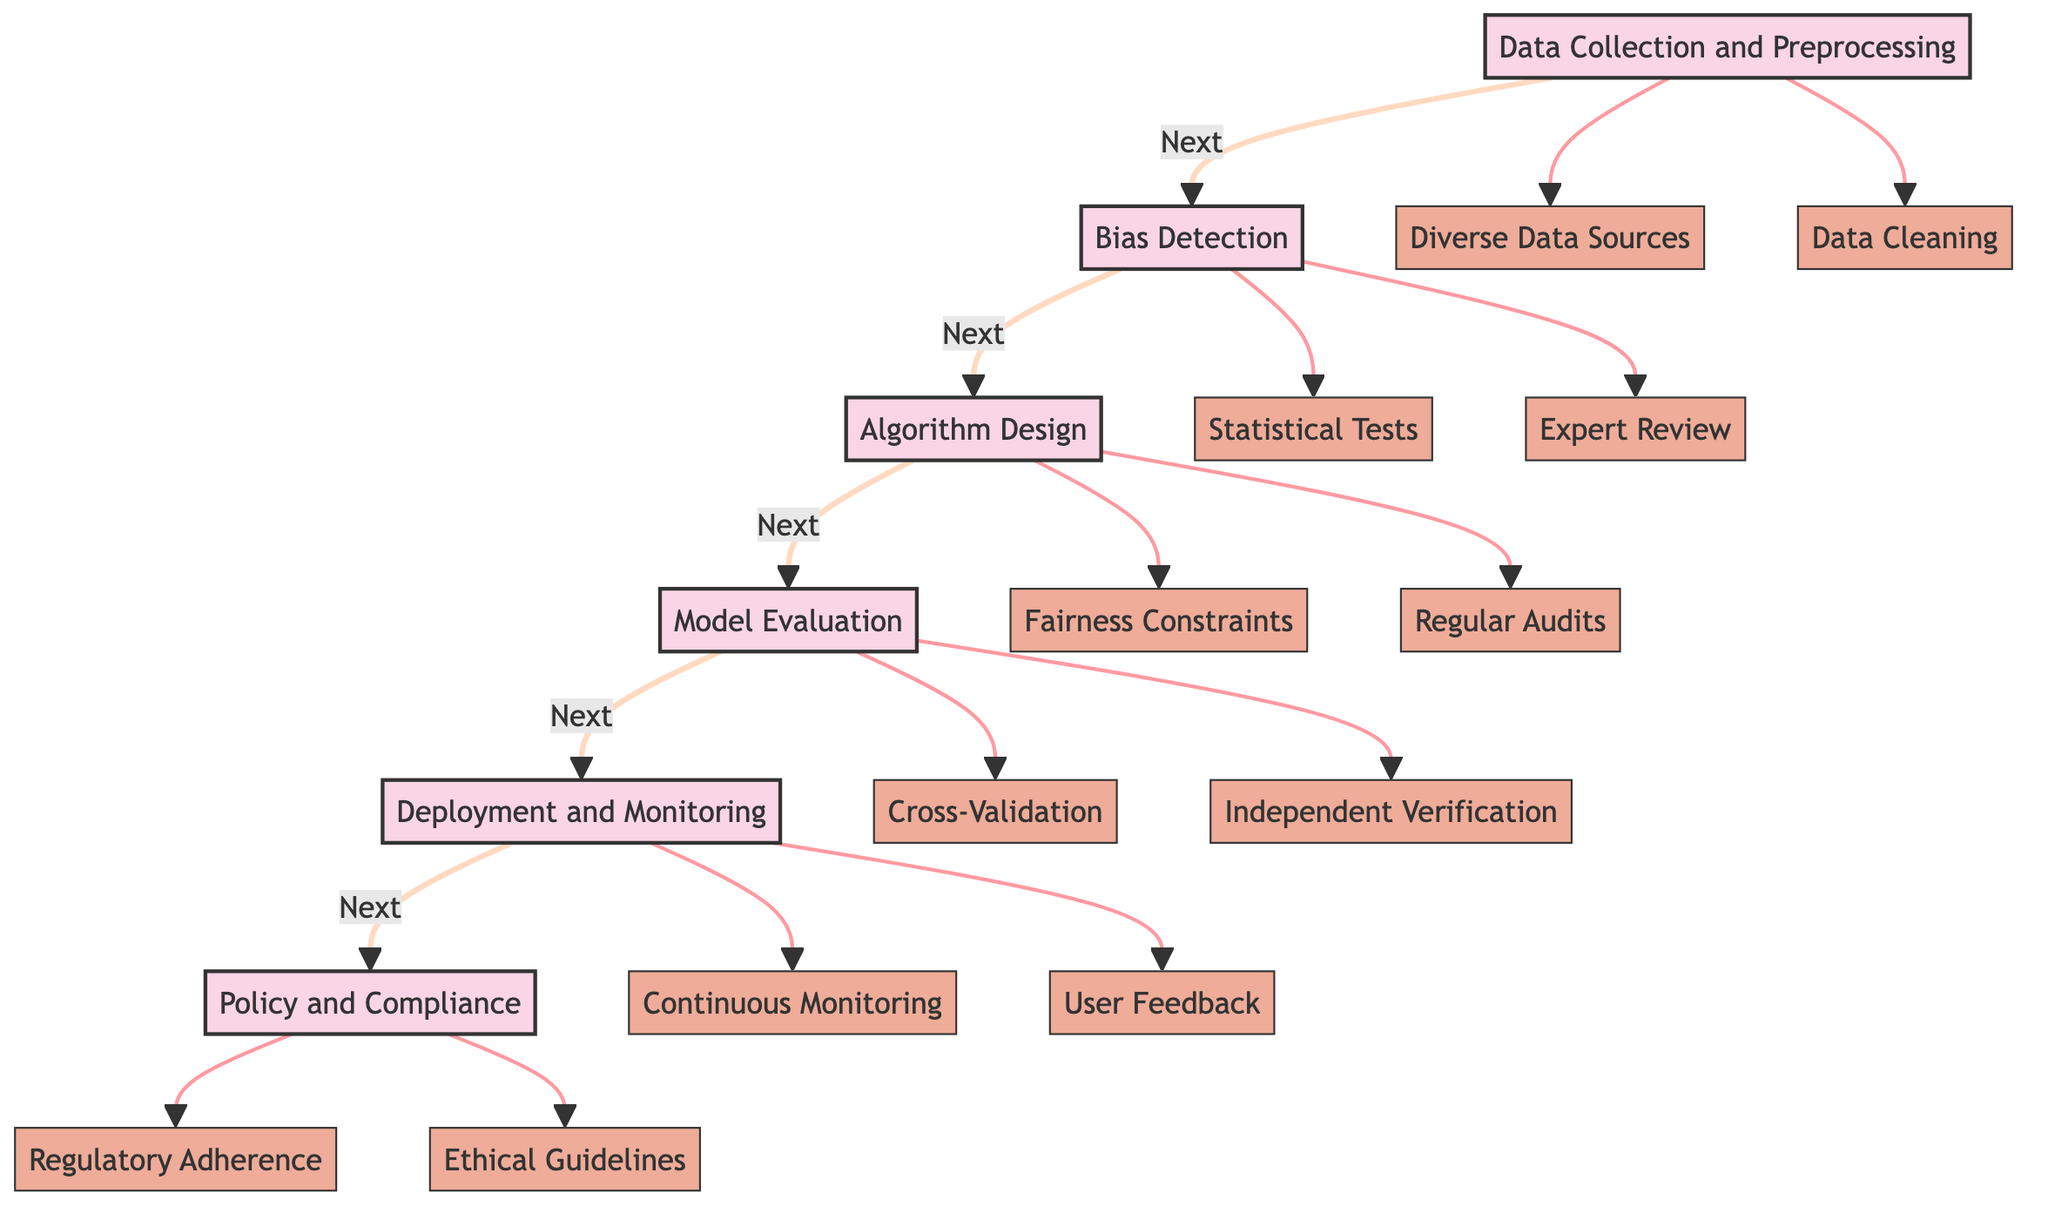What is the first step in the pathway? The diagram indicates that the first step in the pathway is "Data Collection and Preprocessing." This is the starting point of the clinical recommendations process as shown by the arrow leading from A to B.
Answer: Data Collection and Preprocessing How many main steps are shown in the diagram? The diagram consists of six main steps: 1) Data Collection and Preprocessing, 2) Bias Detection, 3) Algorithm Design, 4) Model Evaluation, 5) Deployment and Monitoring, 6) Policy and Compliance. This can be counted from the steps indicated in the flow.
Answer: Six What are the two elements under "Bias Detection"? The two elements listed under "Bias Detection" are "Statistical Tests" and "Expert Review." This information is derived from the elements categorized under the Bias Detection step.
Answer: Statistical Tests and Expert Review What step follows "Algorithm Design"? The step following "Algorithm Design" is "Model Evaluation." This can be seen in the flow where the arrow transitions from C to D.
Answer: Model Evaluation What is the relationship between "Data Cleaning" and "Data Collection and Preprocessing"? "Data Cleaning" is one of the two elements under the step "Data Collection and Preprocessing." It is directly connected, illustrated by the flow from A to A2, showing that it is part of the process of gathering and refining data.
Answer: One of the elements What needs to be ensured under "Policy and Compliance"? Under "Policy and Compliance," it is essential to ensure "Regulatory Adherence" and "Ethical Guidelines." This is shown by the two elements listed beneath that step in the diagram.
Answer: Regulatory Adherence and Ethical Guidelines How is fairness incorporated during the "Algorithm Design" step? Fairness is incorporated in the "Algorithm Design" step through "Fairness Constraints," which are specifically put in place during the training phase of the AI model, alongside "Regular Audits" that help maintain fairness over time.
Answer: Fairness Constraints What type of feedback is suggested under "Deployment and Monitoring"? The suggested type of feedback under "Deployment and Monitoring" is "User Feedback." This is indicated in the diagram as an element that contributes to improving fairness in the deployed model.
Answer: User Feedback What is one method mentioned for detecting bias? One method mentioned for detecting bias is "Statistical Tests." This is cited as an element in the Bias Detection step of the pathway.
Answer: Statistical Tests 